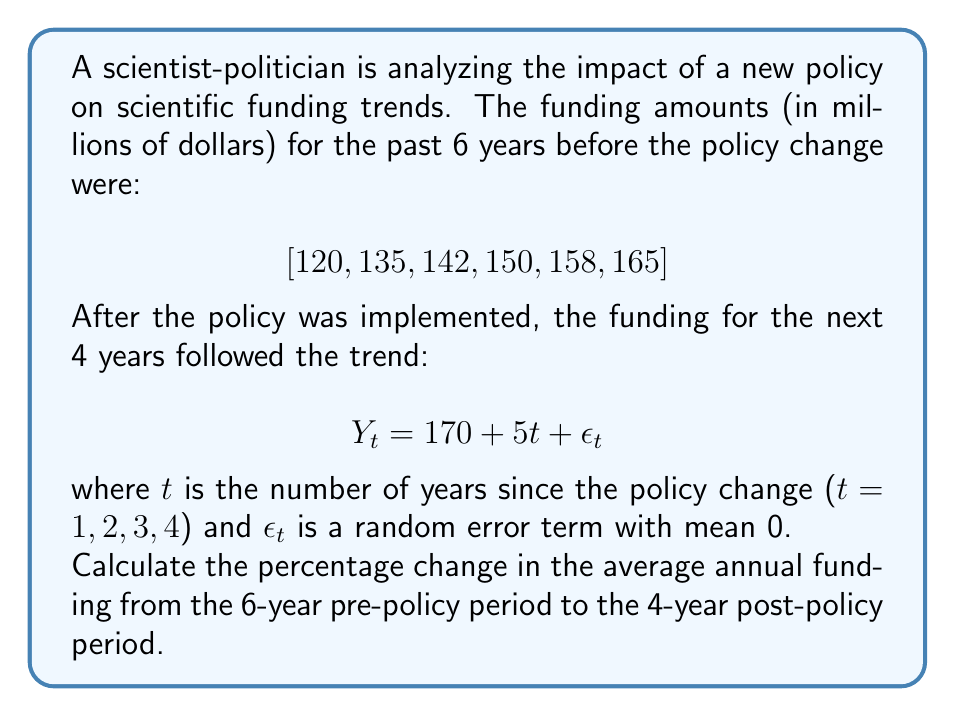Can you answer this question? To solve this problem, we need to follow these steps:

1. Calculate the average annual funding for the pre-policy period:
   $$\text{Pre-policy average} = \frac{120 + 135 + 142 + 150 + 158 + 165}{6} = \frac{870}{6} = 145$$

2. Calculate the average annual funding for the post-policy period:
   For the post-policy period, we use the given equation: $Y_t = 170 + 5t + \epsilon_t$
   
   We need to calculate the funding for each year:
   Year 1 (t=1): $Y_1 = 170 + 5(1) = 175$
   Year 2 (t=2): $Y_2 = 170 + 5(2) = 180$
   Year 3 (t=3): $Y_3 = 170 + 5(3) = 185$
   Year 4 (t=4): $Y_4 = 170 + 5(4) = 190$

   Note: We ignore $\epsilon_t$ as it has a mean of 0 and doesn't affect the average.

   $$\text{Post-policy average} = \frac{175 + 180 + 185 + 190}{4} = \frac{730}{4} = 182.5$$

3. Calculate the percentage change:
   $$\text{Percentage change} = \frac{\text{Post-policy average} - \text{Pre-policy average}}{\text{Pre-policy average}} \times 100\%$$
   
   $$= \frac{182.5 - 145}{145} \times 100\% = \frac{37.5}{145} \times 100\% \approx 25.86\%$$
Answer: The percentage change in the average annual funding from the 6-year pre-policy period to the 4-year post-policy period is approximately 25.86%. 